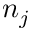Convert formula to latex. <formula><loc_0><loc_0><loc_500><loc_500>n _ { j }</formula> 